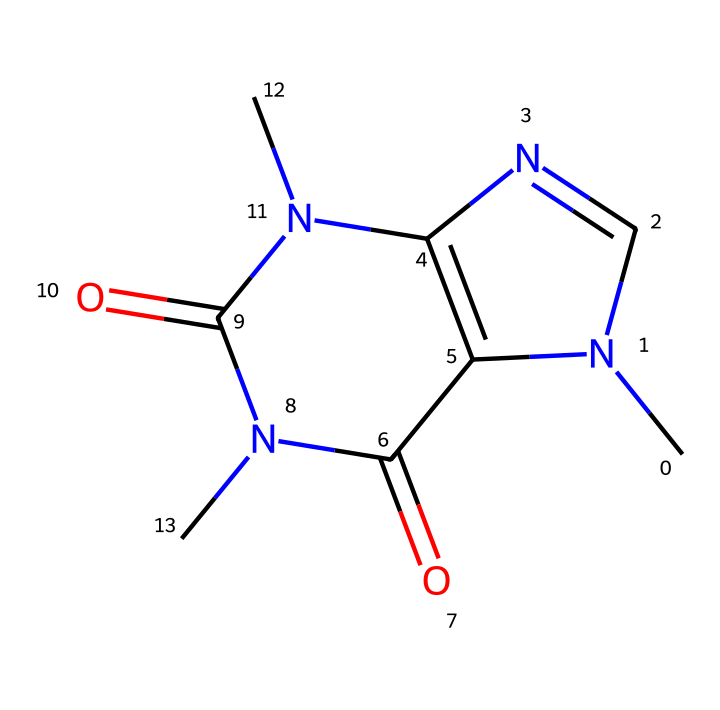How many carbon atoms are in caffeine? By analyzing the SMILES representation, we can count the number of carbon (C) atoms present. The structure includes a total of 8 carbon atoms.
Answer: 8 What is the molecular formula of caffeine? The molecular formula is derived from the counts of each type of atom in the SMILES notation. For caffeine, the total is C8H10N4O2, indicating the counts of carbon, hydrogen, nitrogen, and oxygen atoms.
Answer: C8H10N4O2 How many nitrogen atoms are in caffeine? By examining the SMILES representation, we can identify the number of nitrogen (N) atoms. The structure reveals 4 nitrogen atoms present in caffeine.
Answer: 4 What functional group is present in caffeine? Reviewing the structure, we can see the presence of carbonyl (C=O) groups, which are characteristic functional groups found in many medicinal compounds, including caffeine.
Answer: carbonyl What type of compound is caffeine categorized as? Given that caffeine acts as a stimulant and has a specific nitrogen-containing ring structure called a purine, it is categorized as an alkaloid.
Answer: alkaloid What is the main reason for caffeine's stimulant effect? The presence of nitrogen atoms affects the interaction with adenosine receptors in the brain, which is primarily responsible for its stimulant effects. This interaction leads to increased alertness and reduced fatigue.
Answer: adenosine receptors What is the total number of oxygen atoms in caffeine? From the SMILES representation, we can count the oxygen (O) atoms present. Caffeine contains 2 oxygen atoms in its structure.
Answer: 2 